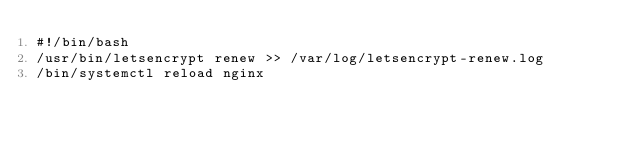<code> <loc_0><loc_0><loc_500><loc_500><_Bash_>#!/bin/bash
/usr/bin/letsencrypt renew >> /var/log/letsencrypt-renew.log
/bin/systemctl reload nginx
</code> 